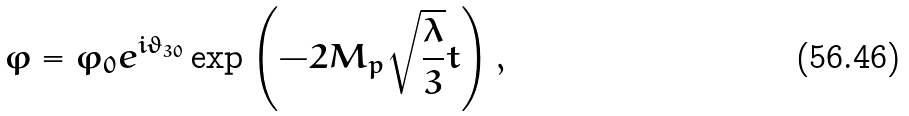Convert formula to latex. <formula><loc_0><loc_0><loc_500><loc_500>\varphi = \varphi _ { 0 } e ^ { i \vartheta _ { 3 0 } } \exp \left ( - 2 M _ { p } \sqrt { \frac { \lambda } { 3 } } t \right ) ,</formula> 